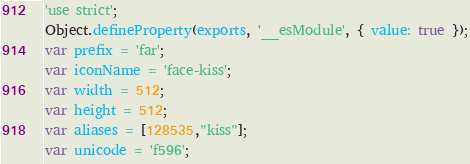Convert code to text. <code><loc_0><loc_0><loc_500><loc_500><_JavaScript_>'use strict';
Object.defineProperty(exports, '__esModule', { value: true });
var prefix = 'far';
var iconName = 'face-kiss';
var width = 512;
var height = 512;
var aliases = [128535,"kiss"];
var unicode = 'f596';</code> 